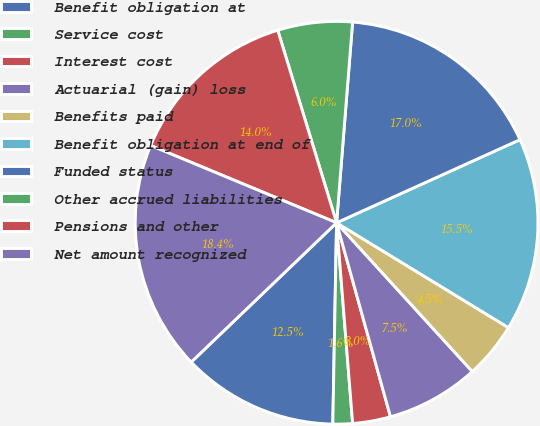Convert chart. <chart><loc_0><loc_0><loc_500><loc_500><pie_chart><fcel>Benefit obligation at<fcel>Service cost<fcel>Interest cost<fcel>Actuarial (gain) loss<fcel>Benefits paid<fcel>Benefit obligation at end of<fcel>Funded status<fcel>Other accrued liabilities<fcel>Pensions and other<fcel>Net amount recognized<nl><fcel>12.54%<fcel>1.57%<fcel>3.04%<fcel>7.46%<fcel>4.51%<fcel>15.49%<fcel>16.96%<fcel>5.99%<fcel>14.01%<fcel>18.43%<nl></chart> 